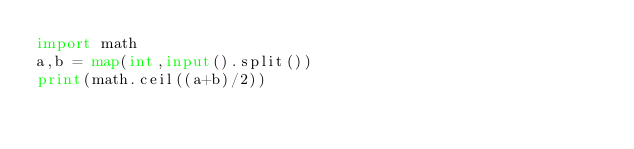<code> <loc_0><loc_0><loc_500><loc_500><_Python_>import math
a,b = map(int,input().split())
print(math.ceil((a+b)/2))
</code> 